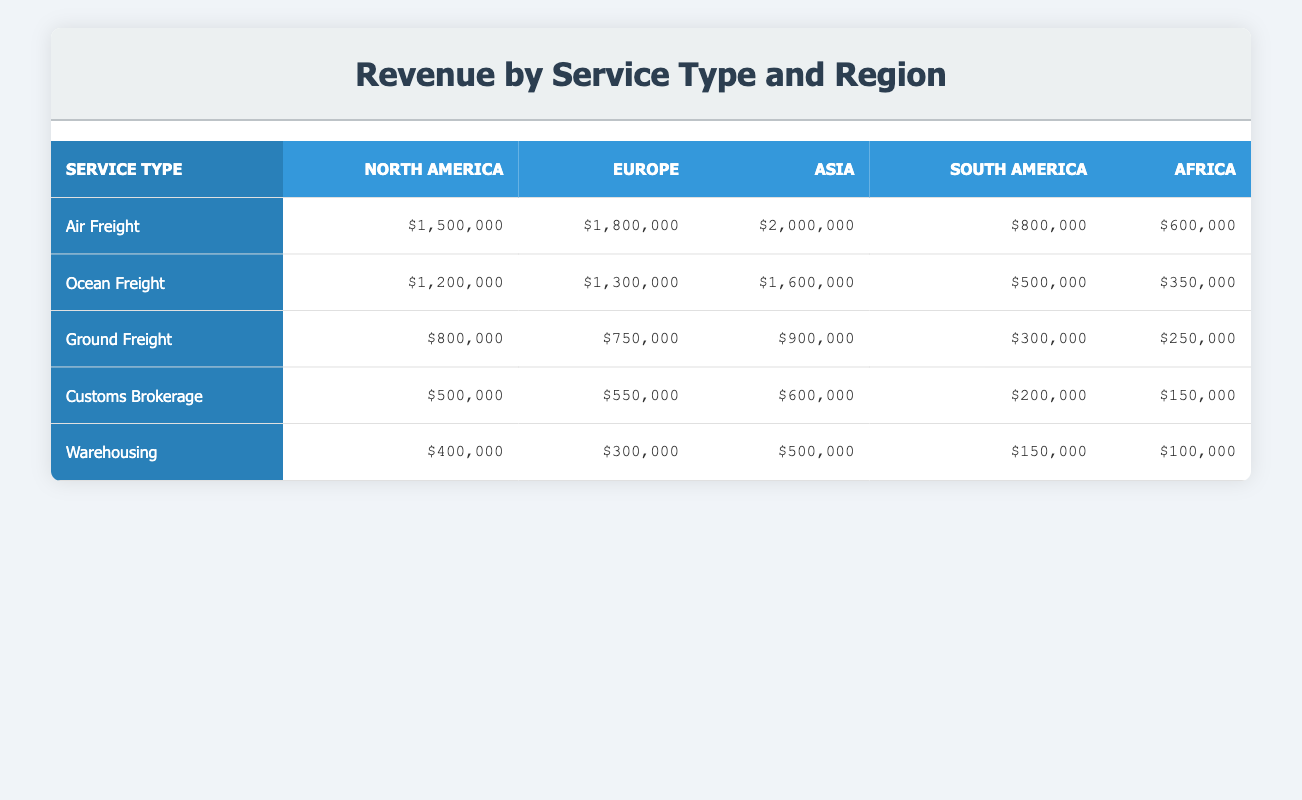What is the total revenue generated by Air Freight in Asia? The revenue generated by Air Freight in Asia is listed in the table as $2,000,000.
Answer: $2,000,000 Which service type generated the most revenue in North America? By looking at the North America column, Air Freight shows the highest revenue of $1,500,000 compared to other service types.
Answer: Air Freight What is the revenue difference between Ocean Freight in Europe and Ocean Freight in South America? The revenue for Ocean Freight in Europe is $1,300,000, while in South America it is $500,000. The difference is $1,300,000 - $500,000 = $800,000.
Answer: $800,000 Is the revenue for Ground Freight in Asia greater than the total revenue for Customs Brokerage across all regions? The revenue for Ground Freight in Asia is $900,000. Calculating Customs Brokerage revenue across all regions gives $500,000 + $550,000 + $600,000 + $200,000 + $150,000 = $2,100,000, which is greater than $900,000.
Answer: No What is the total revenue generated from Warehousing across all regions? The total revenue for Warehousing in all regions is calculated by adding the values: $400,000 (North America) + $300,000 (Europe) + $500,000 (Asia) + $150,000 (South America) + $100,000 (Africa) = $1,450,000.
Answer: $1,450,000 In which region is the revenue for Customs Brokerage the lowest? The table shows the revenue for Customs Brokerage: North America $500,000, Europe $550,000, Asia $600,000, South America $200,000, Africa $150,000. The lowest value is in Africa at $150,000.
Answer: Africa What is the average revenue from Ocean Freight across all regions? The revenue from Ocean Freight is: North America $1,200,000, Europe $1,300,000, Asia $1,600,000, South America $500,000, Africa $350,000. The total is $1,200,000 + $1,300,000 + $1,600,000 + $500,000 + $350,000 = $4,950,000, which yields an average of $4,950,000 / 5 = $990,000.
Answer: $990,000 Which service type has the highest revenue overall? By examining the total revenues for each service type across all regions and adding them together: Air Freight totals $5,100,000, Ocean Freight $4,950,000, Ground Freight $3,000,000, Customs Brokerage $2,000,000, Warehousing $1,450,000. The highest is Air Freight with $5,100,000.
Answer: Air Freight How much revenue did South America generate from all service types combined? Computing the total revenue for South America gives: Air Freight $800,000, Ocean Freight $500,000, Ground Freight $300,000, Customs Brokerage $200,000, and Warehousing $150,000. The total is $800,000 + $500,000 + $300,000 + $200,000 + $150,000 = $1,950,000.
Answer: $1,950,000 